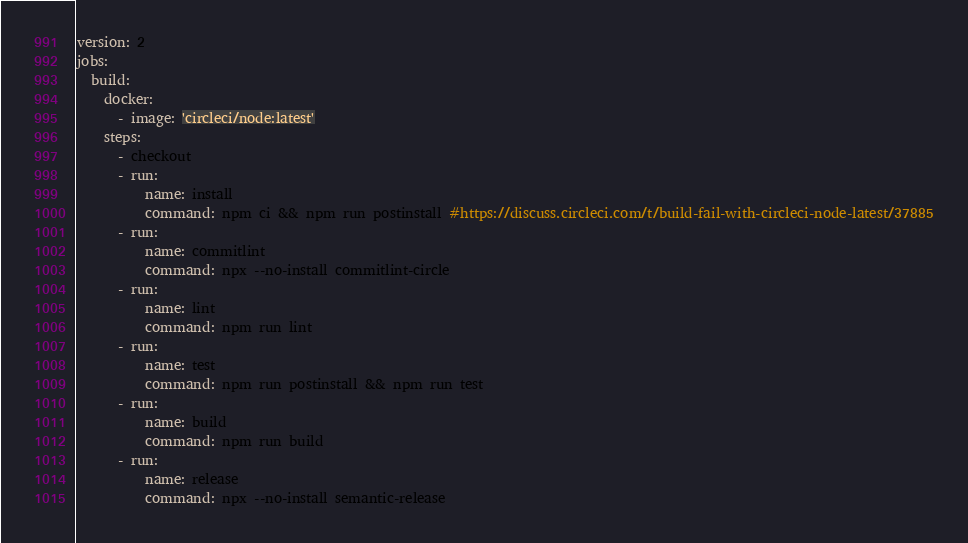Convert code to text. <code><loc_0><loc_0><loc_500><loc_500><_YAML_>version: 2
jobs:
  build:
    docker:
      - image: 'circleci/node:latest'
    steps:
      - checkout
      - run:
          name: install
          command: npm ci && npm run postinstall #https://discuss.circleci.com/t/build-fail-with-circleci-node-latest/37885
      - run:
          name: commitlint
          command: npx --no-install commitlint-circle
      - run:
          name: lint
          command: npm run lint
      - run:
          name: test
          command: npm run postinstall && npm run test
      - run:
          name: build
          command: npm run build
      - run:
          name: release
          command: npx --no-install semantic-release
</code> 